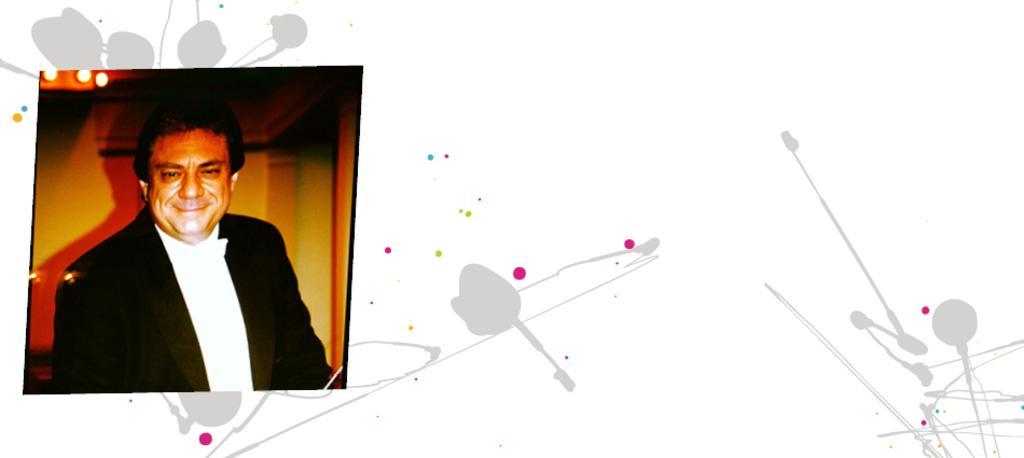How would you summarize this image in a sentence or two? This image consists of a photograph of a person. He is wearing a black suit and white shirt. This image looks like it is edited. 